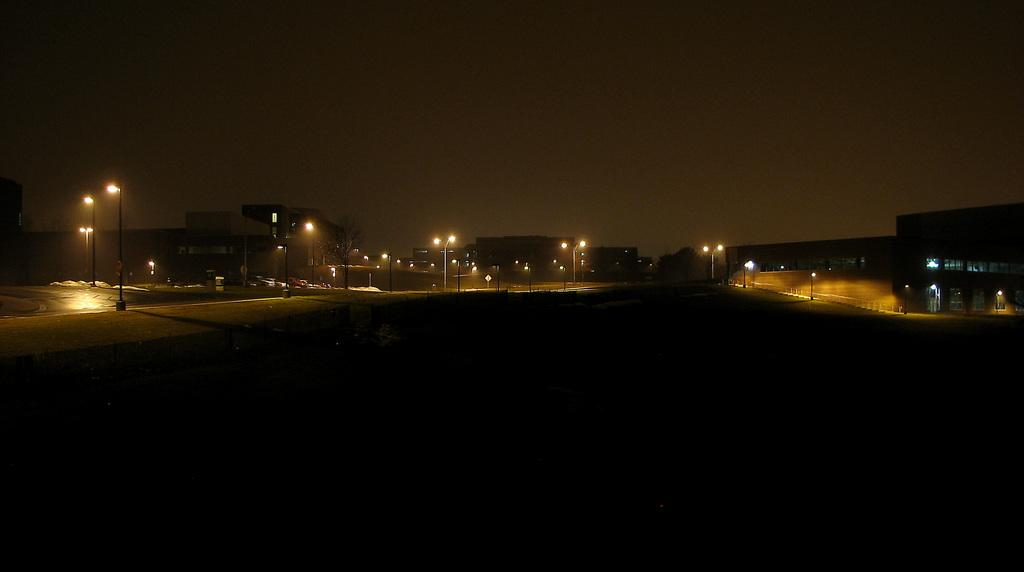What type of structures can be seen in the background of the image? There are buildings in the background of the image. What type of object is present in the background of the image, providing illumination? There is a streetlight in the background of the image. What letters are being burned by the flame in the image? There is no flame or letters present in the image. How is the lock being used in the image? There is no lock present in the image. 